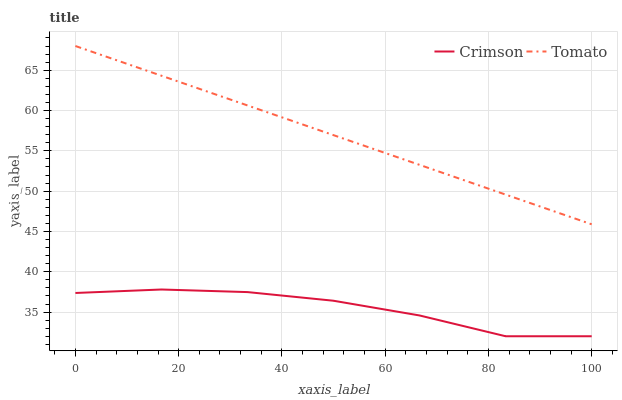Does Crimson have the minimum area under the curve?
Answer yes or no. Yes. Does Tomato have the maximum area under the curve?
Answer yes or no. Yes. Does Tomato have the minimum area under the curve?
Answer yes or no. No. Is Tomato the smoothest?
Answer yes or no. Yes. Is Crimson the roughest?
Answer yes or no. Yes. Is Tomato the roughest?
Answer yes or no. No. Does Tomato have the lowest value?
Answer yes or no. No. Is Crimson less than Tomato?
Answer yes or no. Yes. Is Tomato greater than Crimson?
Answer yes or no. Yes. Does Crimson intersect Tomato?
Answer yes or no. No. 